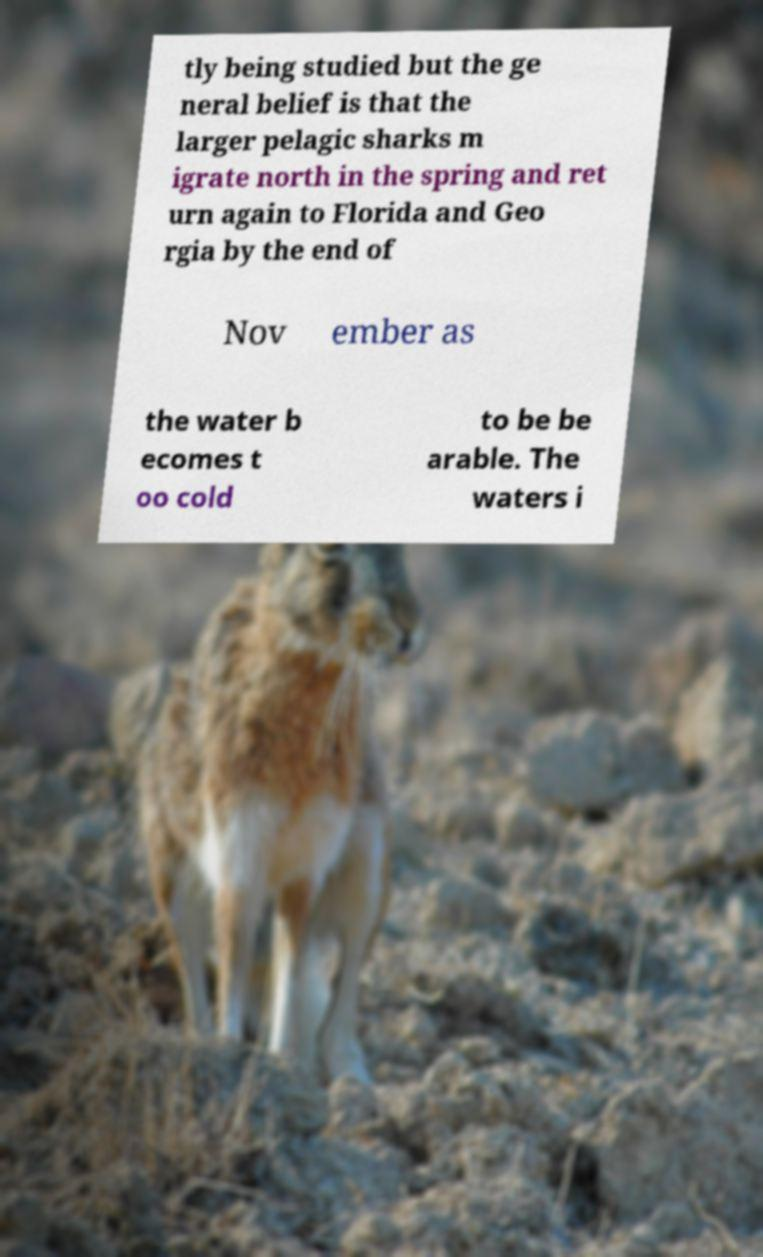Could you extract and type out the text from this image? tly being studied but the ge neral belief is that the larger pelagic sharks m igrate north in the spring and ret urn again to Florida and Geo rgia by the end of Nov ember as the water b ecomes t oo cold to be be arable. The waters i 